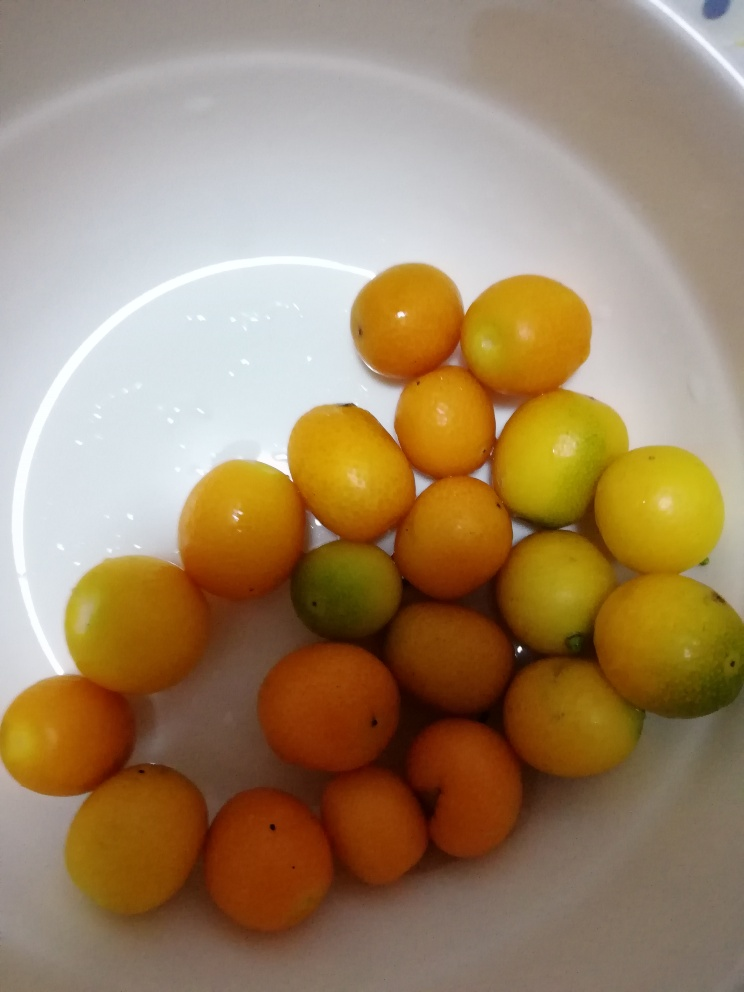Considering the lighting in the image, what time of day do you think it was taken? The lighting in the image is soft and diffused, lacking harsh shadows, which may indicate it was taken during the day under natural light, possibly in a bright indoor space or on a cloudy day where the sunlight is not direct. 